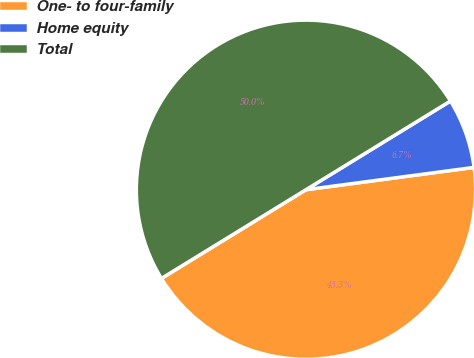Convert chart to OTSL. <chart><loc_0><loc_0><loc_500><loc_500><pie_chart><fcel>One- to four-family<fcel>Home equity<fcel>Total<nl><fcel>43.34%<fcel>6.66%<fcel>50.0%<nl></chart> 